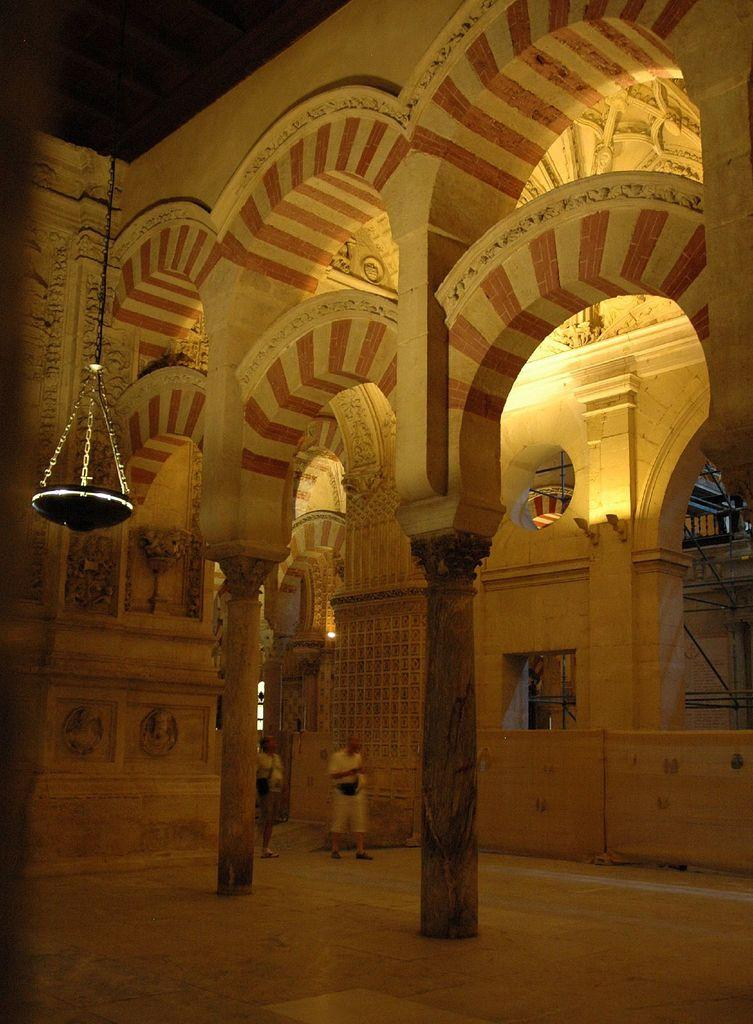What is the main subject in the middle of the image? There is a building present in the middle of the image. What can be seen inside the building? Two persons are standing in the building. What type of cracker is being used as a prop in the scene? There is no cracker present in the image, nor is there a scene depicted. 